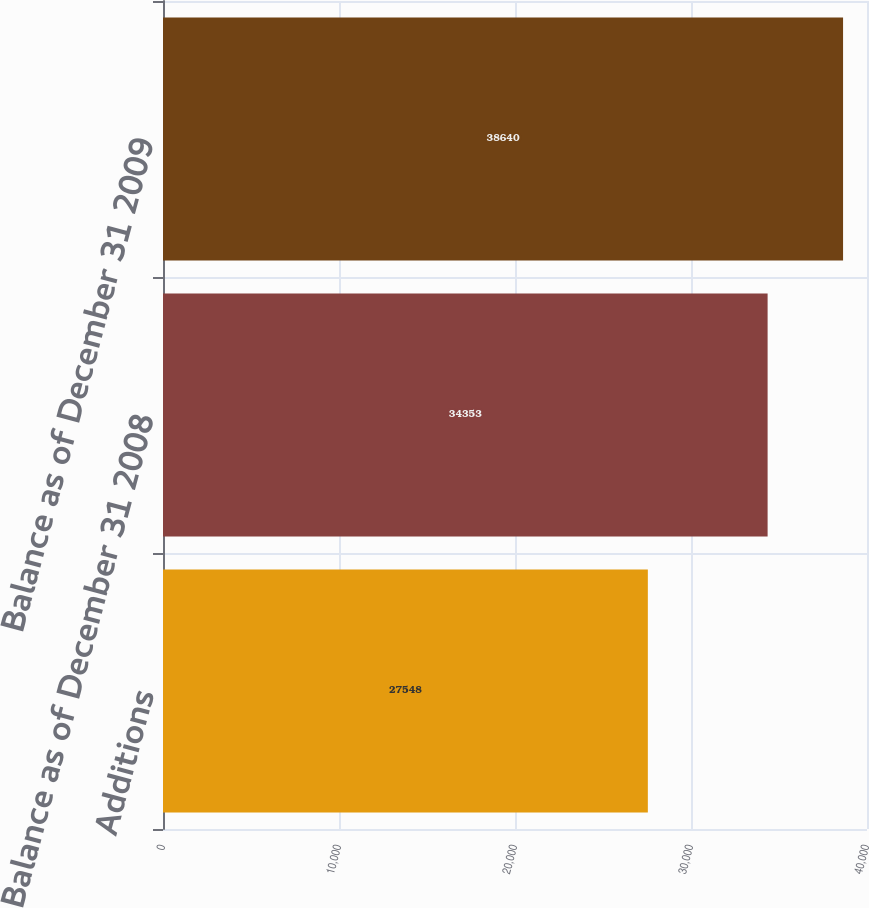Convert chart to OTSL. <chart><loc_0><loc_0><loc_500><loc_500><bar_chart><fcel>Additions<fcel>Balance as of December 31 2008<fcel>Balance as of December 31 2009<nl><fcel>27548<fcel>34353<fcel>38640<nl></chart> 